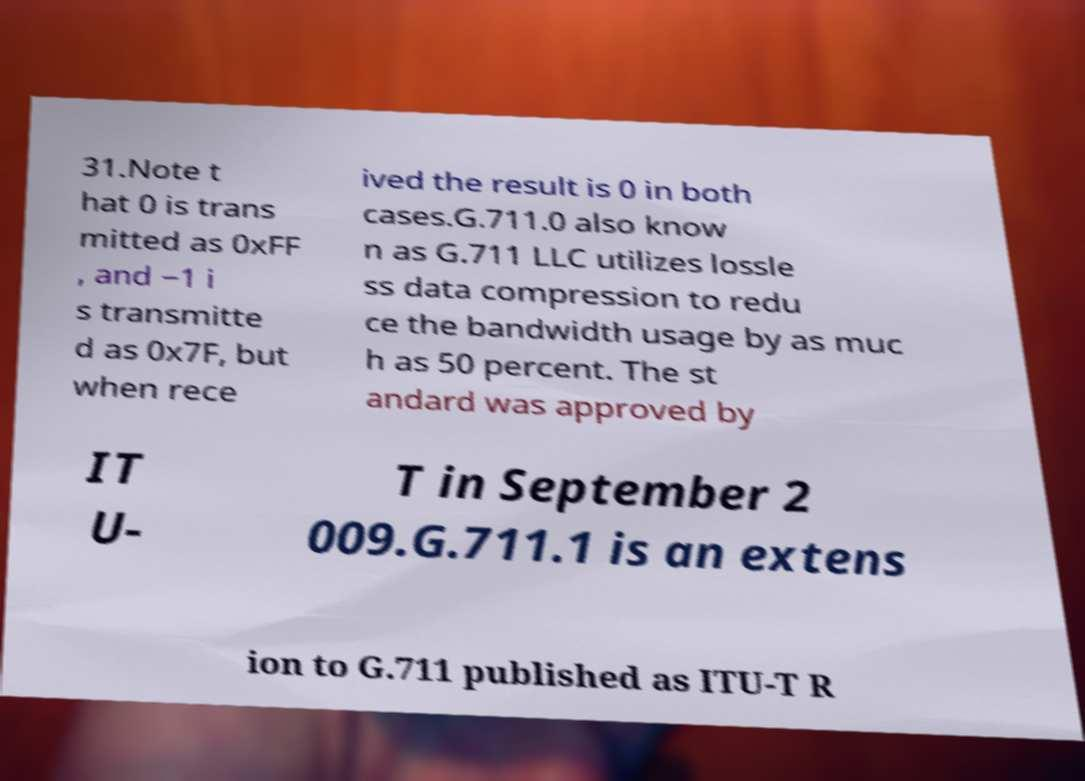There's text embedded in this image that I need extracted. Can you transcribe it verbatim? 31.Note t hat 0 is trans mitted as 0xFF , and −1 i s transmitte d as 0x7F, but when rece ived the result is 0 in both cases.G.711.0 also know n as G.711 LLC utilizes lossle ss data compression to redu ce the bandwidth usage by as muc h as 50 percent. The st andard was approved by IT U- T in September 2 009.G.711.1 is an extens ion to G.711 published as ITU-T R 